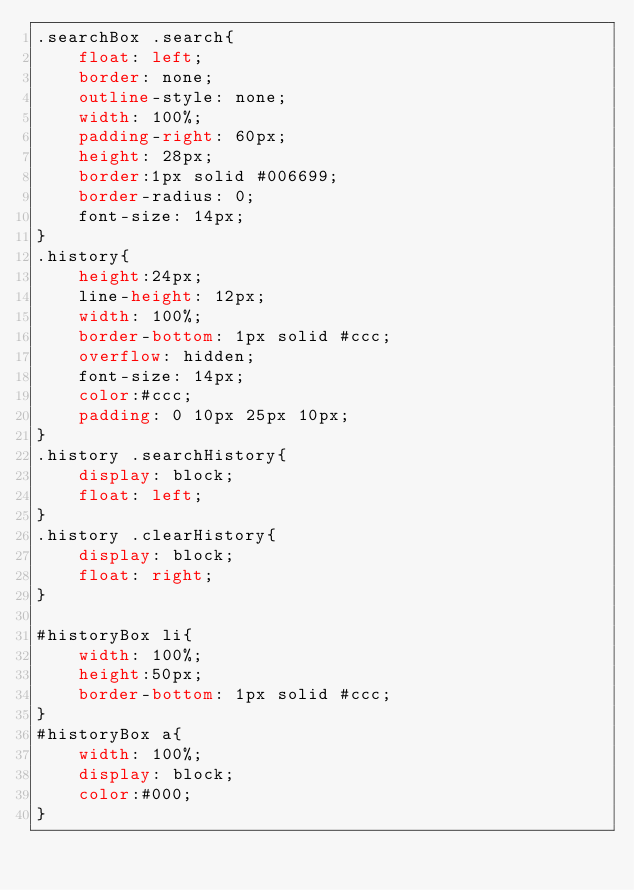Convert code to text. <code><loc_0><loc_0><loc_500><loc_500><_CSS_>.searchBox .search{
	float: left;
	border: none;
	outline-style: none;
	width: 100%; 
	padding-right: 60px;
	height: 28px;
	border:1px solid #006699;
	border-radius: 0;
	font-size: 14px;
}
.history{
	height:24px;
	line-height: 12px;
	width: 100%;
	border-bottom: 1px solid #ccc;
	overflow: hidden;
	font-size: 14px;
	color:#ccc;
	padding: 0 10px 25px 10px;
}
.history .searchHistory{
	display: block;
	float: left;
}
.history .clearHistory{
	display: block;
	float: right;
}

#historyBox li{
	width: 100%;
	height:50px;
	border-bottom: 1px solid #ccc;
}
#historyBox a{
	width: 100%;
	display: block;
	color:#000;
}</code> 